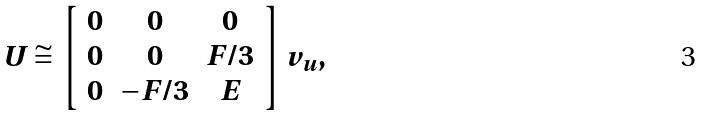Convert formula to latex. <formula><loc_0><loc_0><loc_500><loc_500>U \cong \left [ \begin{array} { c c c } 0 & 0 & 0 \\ 0 & 0 & F / 3 \\ 0 & - F / 3 & E \end{array} \right ] v _ { u } ,</formula> 